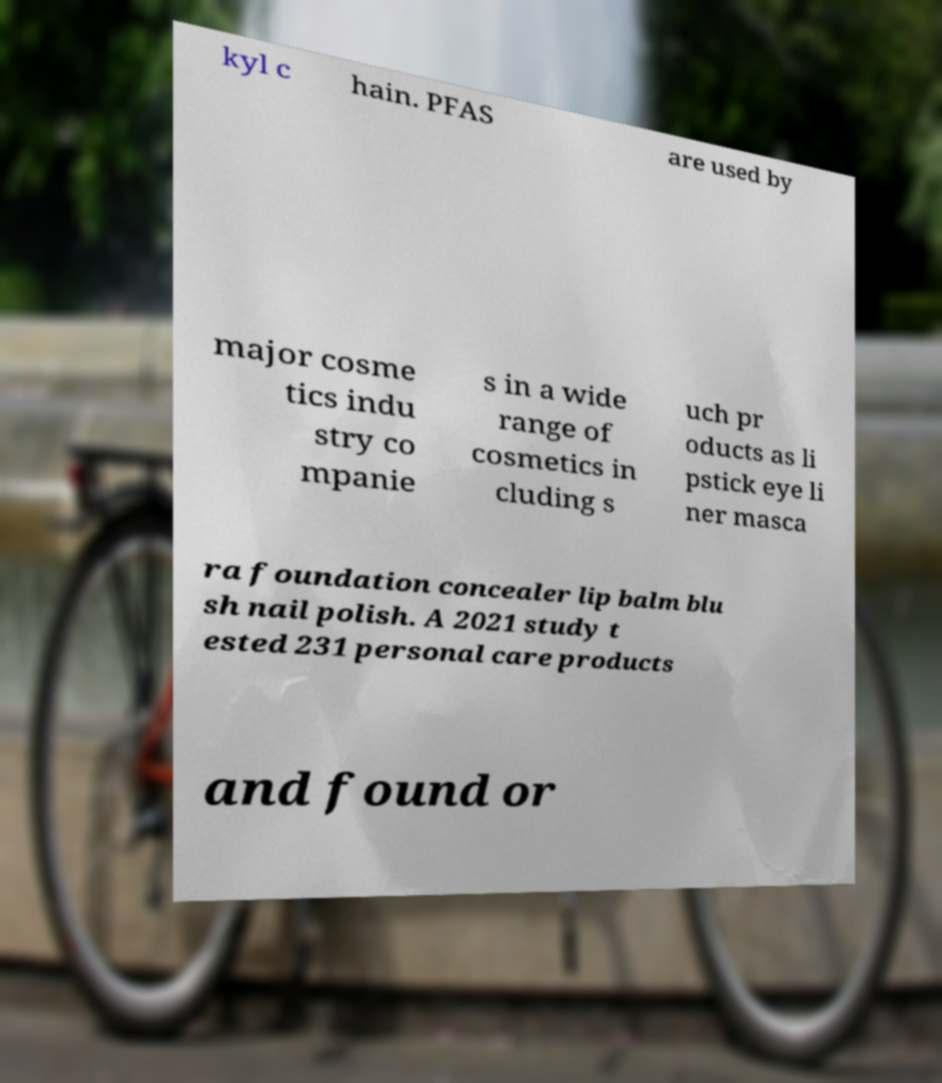There's text embedded in this image that I need extracted. Can you transcribe it verbatim? kyl c hain. PFAS are used by major cosme tics indu stry co mpanie s in a wide range of cosmetics in cluding s uch pr oducts as li pstick eye li ner masca ra foundation concealer lip balm blu sh nail polish. A 2021 study t ested 231 personal care products and found or 